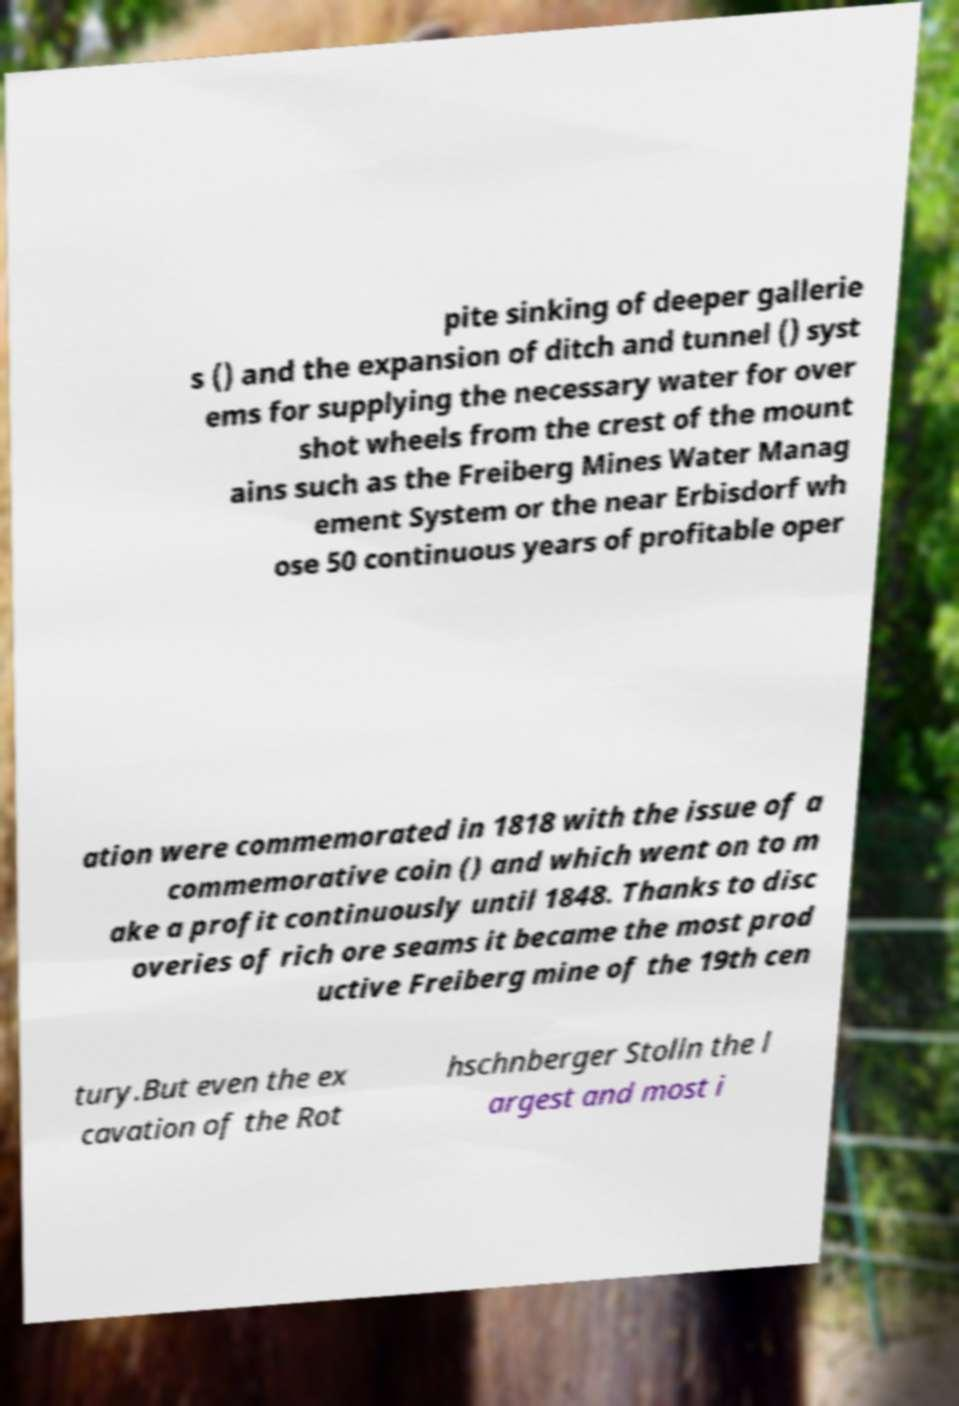Can you accurately transcribe the text from the provided image for me? pite sinking of deeper gallerie s () and the expansion of ditch and tunnel () syst ems for supplying the necessary water for over shot wheels from the crest of the mount ains such as the Freiberg Mines Water Manag ement System or the near Erbisdorf wh ose 50 continuous years of profitable oper ation were commemorated in 1818 with the issue of a commemorative coin () and which went on to m ake a profit continuously until 1848. Thanks to disc overies of rich ore seams it became the most prod uctive Freiberg mine of the 19th cen tury.But even the ex cavation of the Rot hschnberger Stolln the l argest and most i 